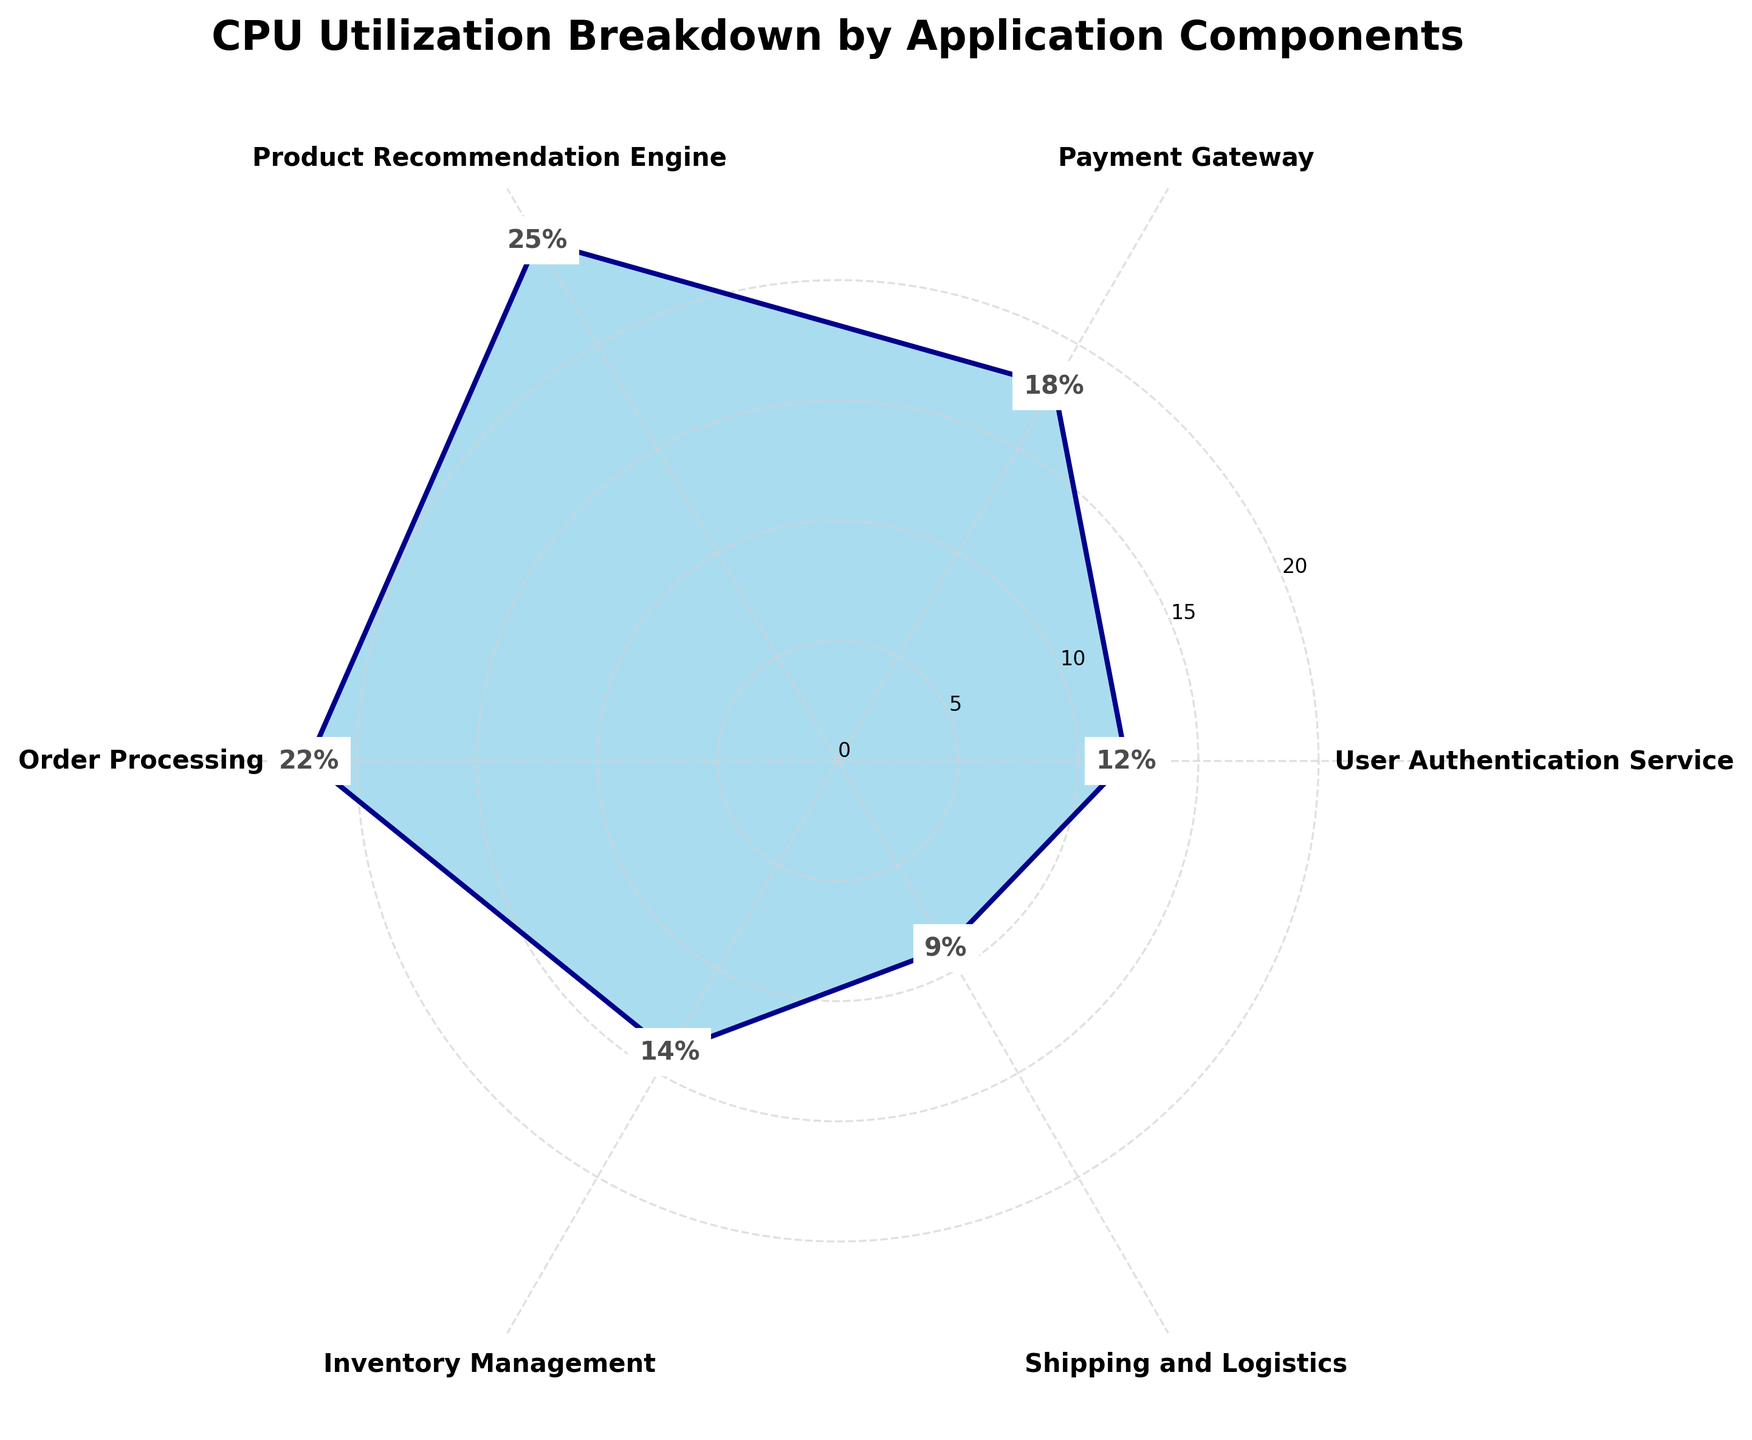What's the title of the chart? The title is located at the top of the chart. It reads "CPU Utilization Breakdown by Application Components."
Answer: CPU Utilization Breakdown by Application Components How many application components are represented in the chart? Each angle in the polar chart represents one application component. Counting these components gives us the total number. There are 6 components: User Authentication Service, Payment Gateway, Product Recommendation Engine, Order Processing, Inventory Management, and Shipping and Logistics.
Answer: 6 Which component shows the highest CPU utilization percentage? By observing the length of the segments and the numeric labels for each, we can identify that the Product Recommendation Engine has the highest CPU utilization at 25%.
Answer: Product Recommendation Engine Is the CPU utilization of the Payment Gateway more than the User Authentication Service? Check the numeric labels for Payment Gateway (18%) and User Authentication Service (12%). Since 18% is greater than 12%, the CPU utilization of the Payment Gateway is indeed more.
Answer: Yes What is the total CPU utilization percentage for all components combined? Add up all the individual CPU utilization percentages. The values are 12 (User Authentication Service) + 18 (Payment Gateway) + 25 (Product Recommendation Engine) + 22 (Order Processing) + 14 (Inventory Management) + 9 (Shipping and Logistics). Thus, the total is 12+18+25+22+14+9 = 100%.
Answer: 100% Which two components together contribute to over one-third (more than 33.33%) of the total CPU utilization? First, combine the percentages of different pairs to find their sum. For instance, combining Product Recommendation Engine (25%) and Order Processing (22%), we get 25 + 22 = 47%, which is more than one-third of 100%.
Answer: Product Recommendation Engine and Order Processing How does the CPU utilization of the Inventory Management compare to Shipping and Logistics? The Inventory Management utilization is 14%, while Shipping and Logistics is 9%. Comparing these values, 14% is greater than 9%.
Answer: Inventory Management utilizes more CPU If the CPU utilization of Inventory Management is reduced by half, what would be the new total CPU utilization? First, calculate half of the Inventory Management's utilization (14% / 2 = 7%). Then, subtract the original utilization and add the new value: 100% (total) - 14% + 7% = 93%.
Answer: 93% Arrange the components in descending order of their CPU utilization percentages. Starting from the highest, the ordered list is: Product Recommendation Engine (25%), Order Processing (22%), Payment Gateway (18%), Inventory Management (14%), User Authentication Service (12%), Shipping and Logistics (9%).
Answer: Product Recommendation Engine, Order Processing, Payment Gateway, Inventory Management, User Authentication Service, Shipping and Logistics 